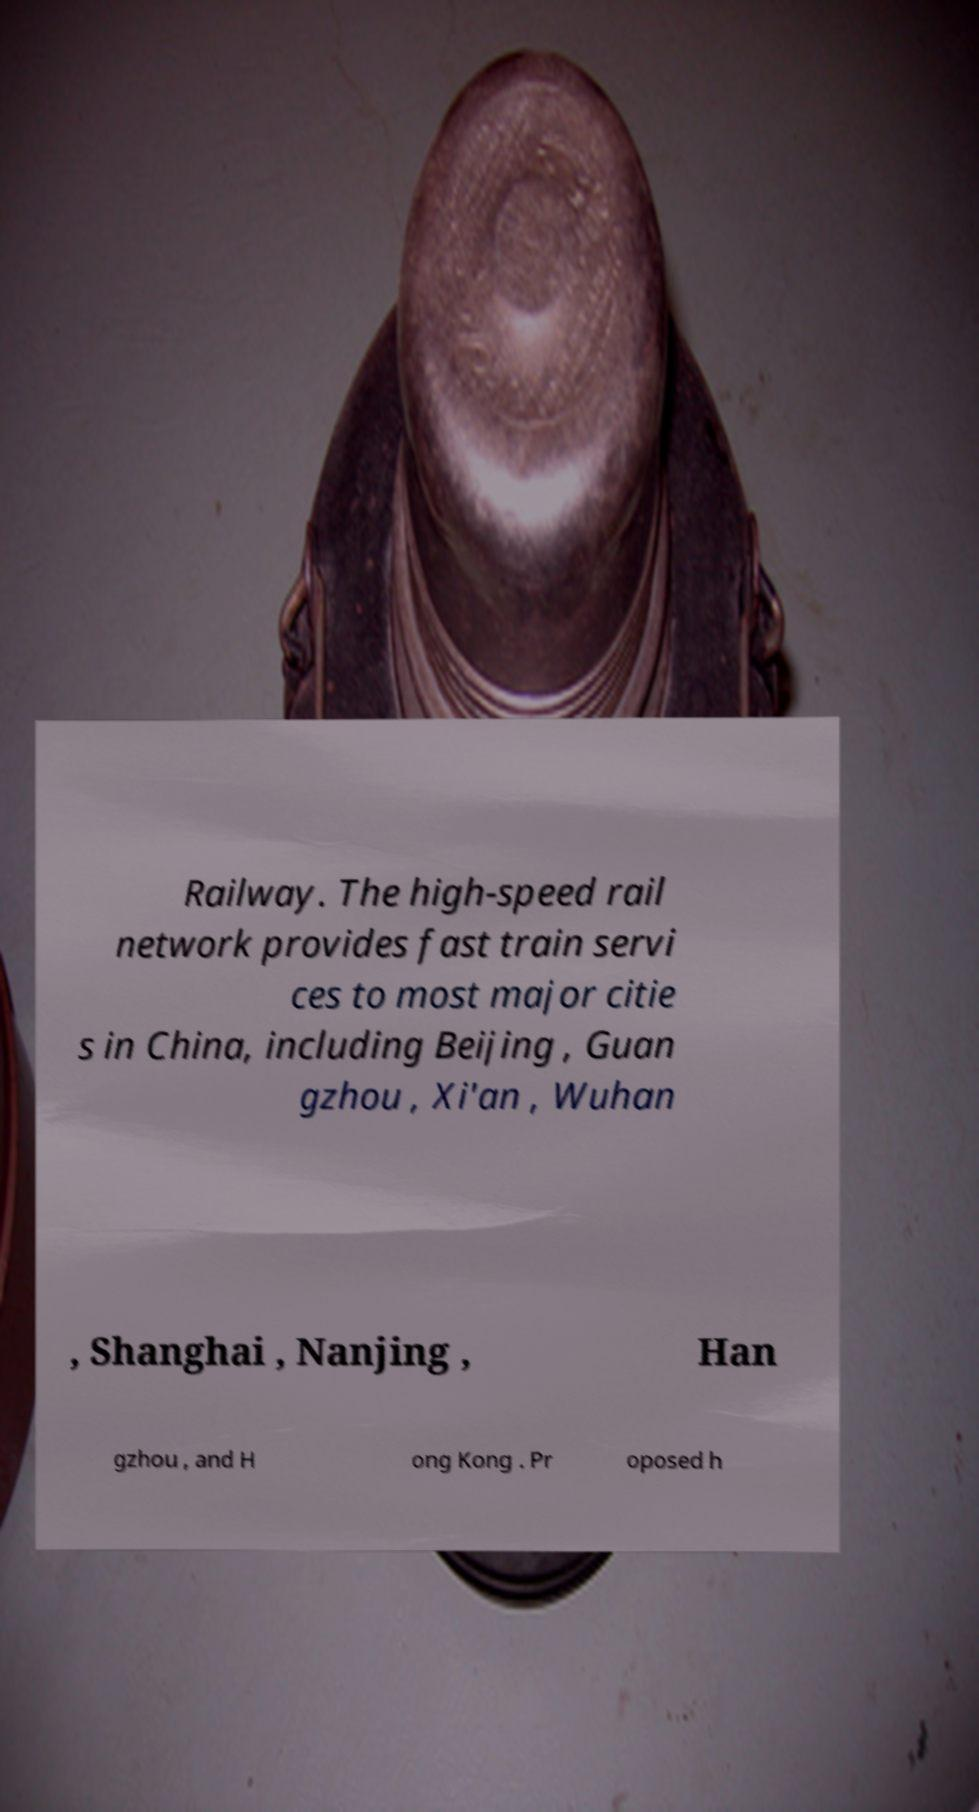Could you extract and type out the text from this image? Railway. The high-speed rail network provides fast train servi ces to most major citie s in China, including Beijing , Guan gzhou , Xi'an , Wuhan , Shanghai , Nanjing , Han gzhou , and H ong Kong . Pr oposed h 